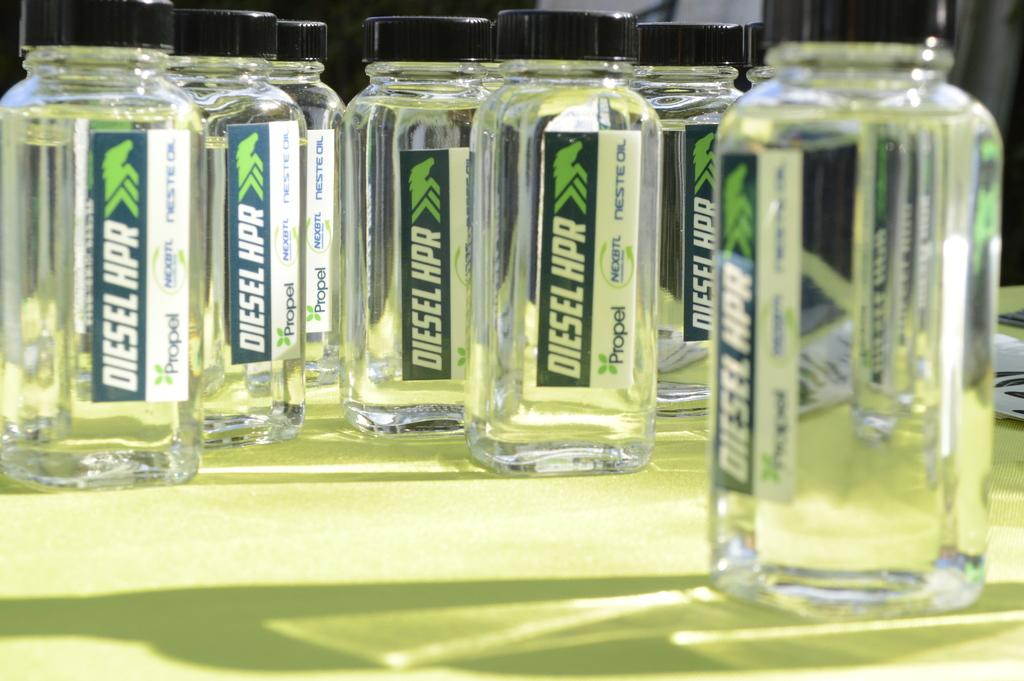Provide a one-sentence caption for the provided image. Bottles have the brand name Diesel on them. 